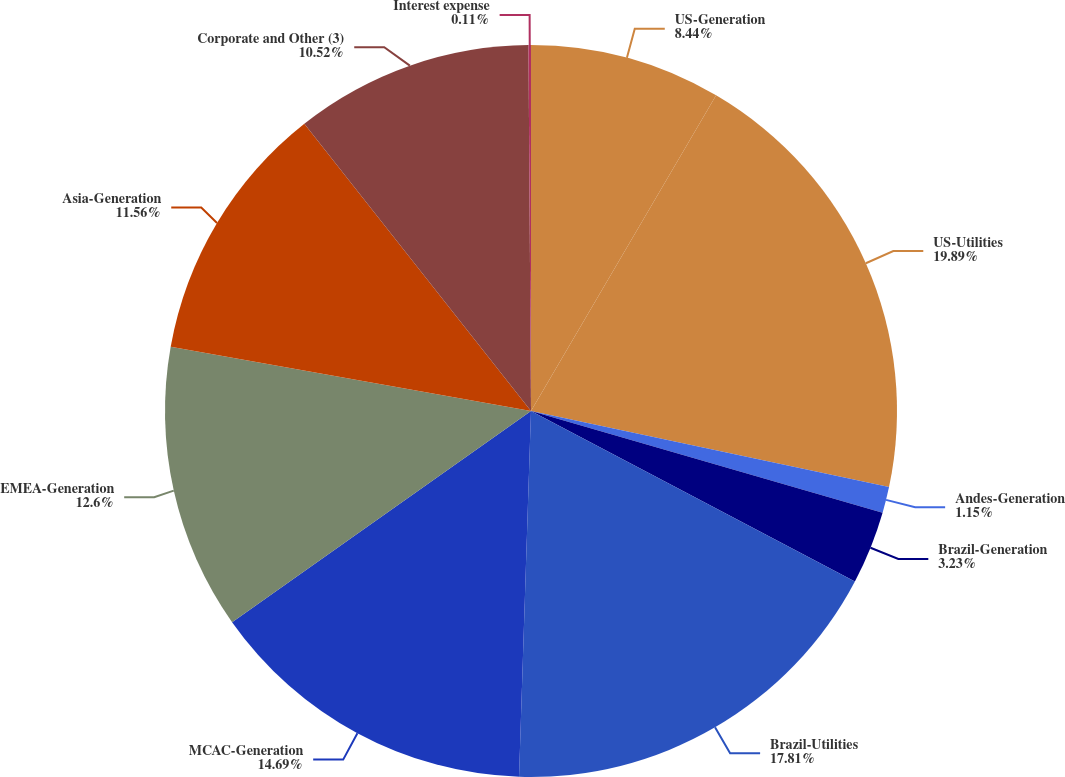Convert chart to OTSL. <chart><loc_0><loc_0><loc_500><loc_500><pie_chart><fcel>US-Generation<fcel>US-Utilities<fcel>Andes-Generation<fcel>Brazil-Generation<fcel>Brazil-Utilities<fcel>MCAC-Generation<fcel>EMEA-Generation<fcel>Asia-Generation<fcel>Corporate and Other (3)<fcel>Interest expense<nl><fcel>8.44%<fcel>19.89%<fcel>1.15%<fcel>3.23%<fcel>17.81%<fcel>14.69%<fcel>12.6%<fcel>11.56%<fcel>10.52%<fcel>0.11%<nl></chart> 